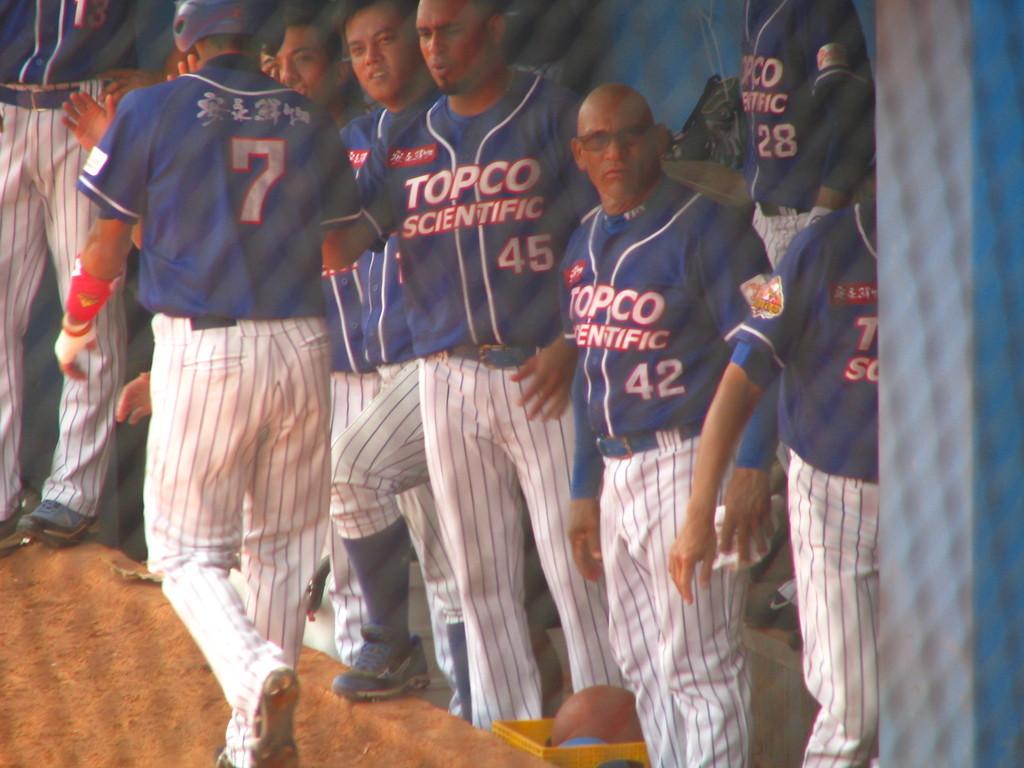What is the number on the player in the front ?
Give a very brief answer. 7. What team do these players play for?
Your answer should be very brief. Topco scientific. 